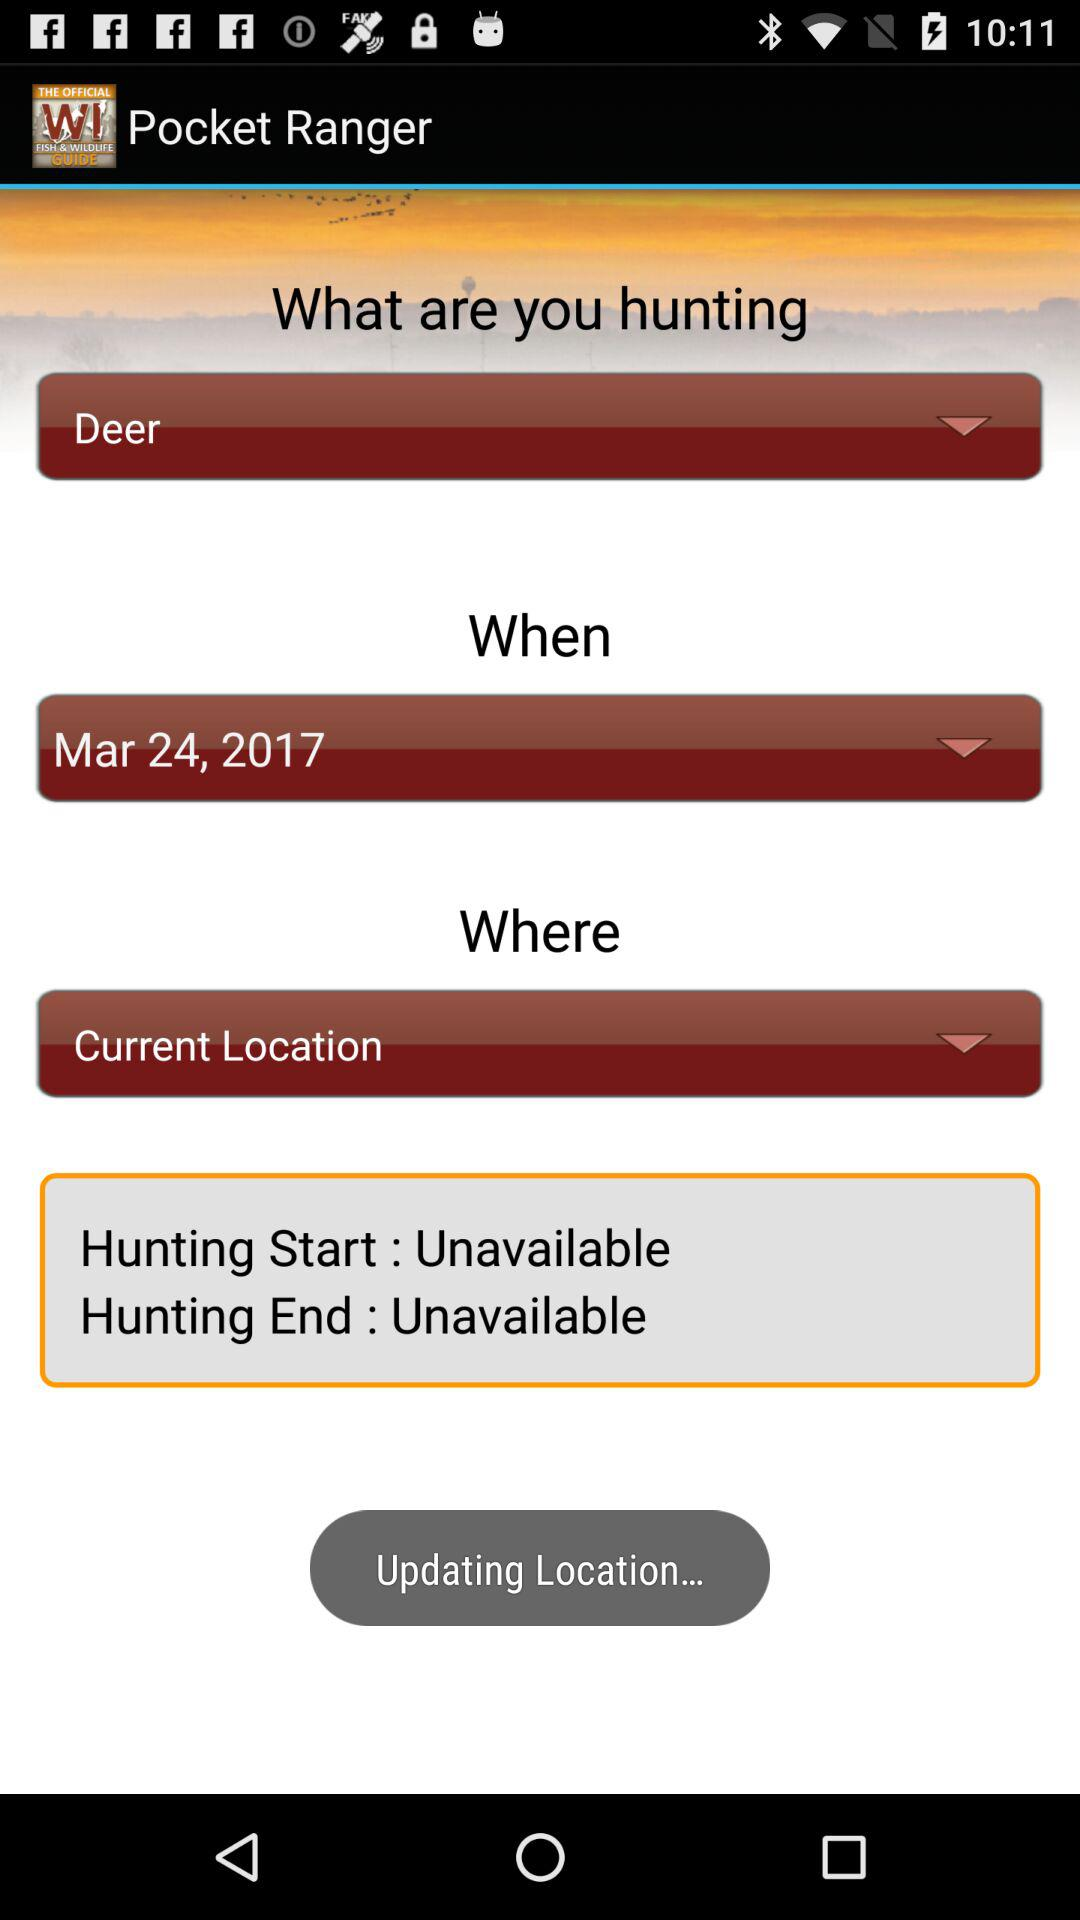What is the status of hunting end? The status is "Unavailable". 